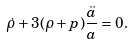Convert formula to latex. <formula><loc_0><loc_0><loc_500><loc_500>\dot { \rho } + 3 ( \rho + p ) \frac { \ddot { a } } { a } = 0 .</formula> 